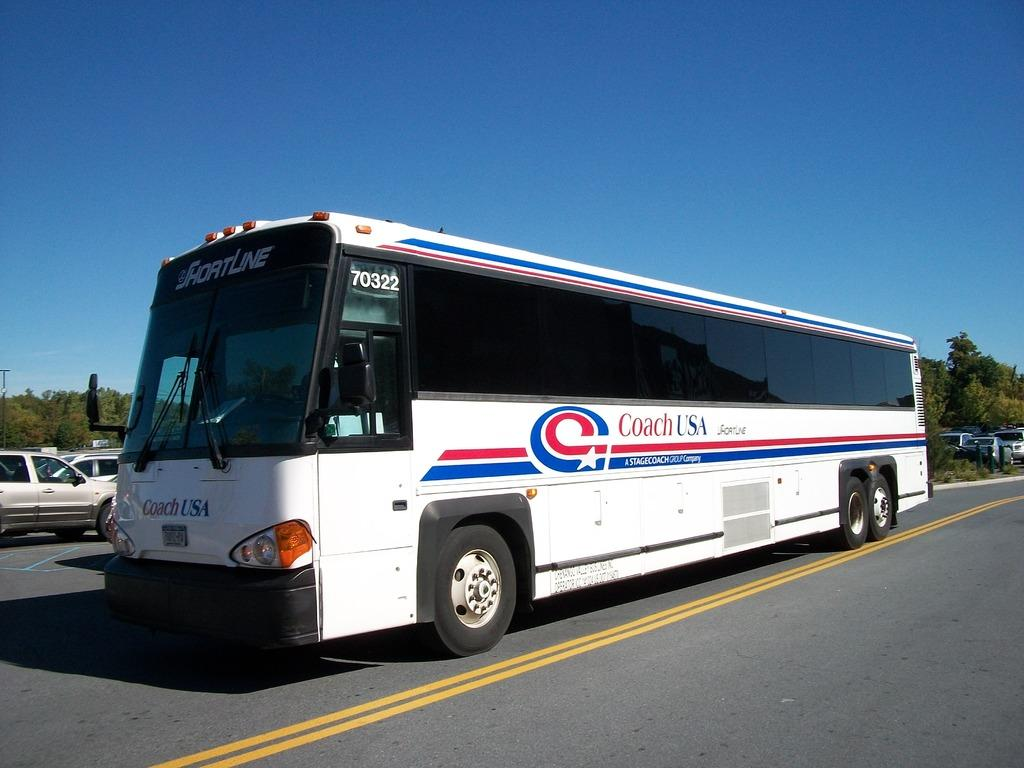What is the main subject in the middle of the picture? There is a bus in the middle of the picture on the road. What other vehicles can be seen on the left side of the picture? There are cars on the left side of the picture. What can be seen in the background of the picture? There are trees and the sky visible in the background of the picture. Can you see any flowers growing on the bus in the image? There are no flowers visible on the bus in the image. 